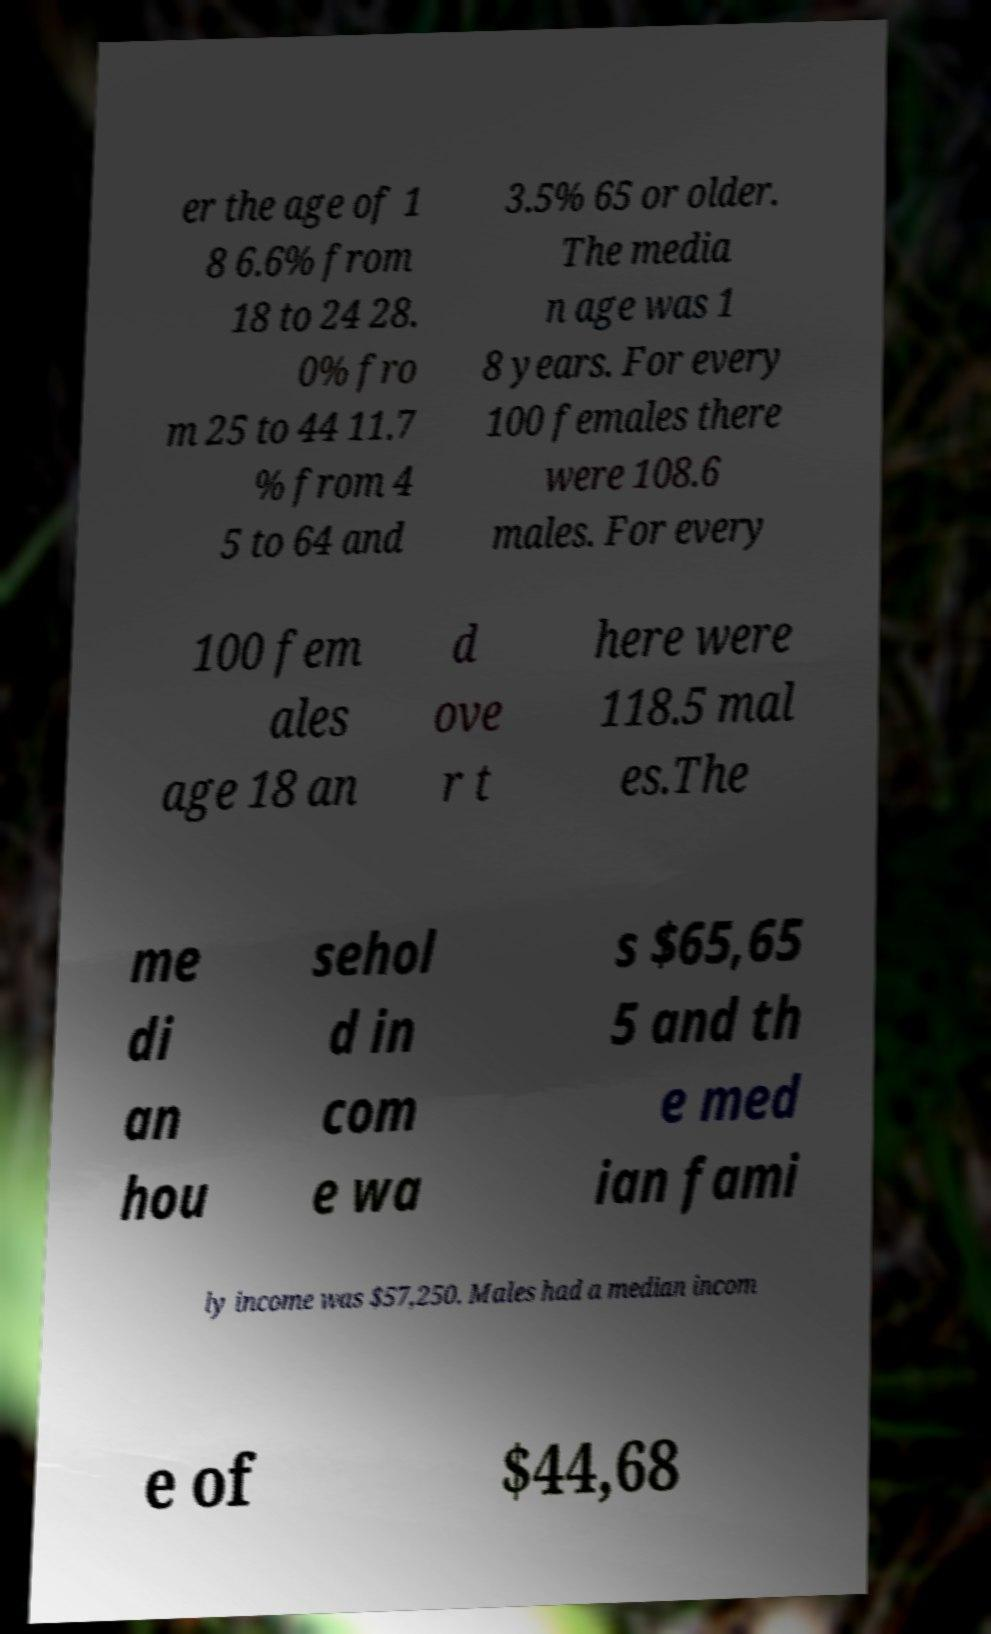There's text embedded in this image that I need extracted. Can you transcribe it verbatim? er the age of 1 8 6.6% from 18 to 24 28. 0% fro m 25 to 44 11.7 % from 4 5 to 64 and 3.5% 65 or older. The media n age was 1 8 years. For every 100 females there were 108.6 males. For every 100 fem ales age 18 an d ove r t here were 118.5 mal es.The me di an hou sehol d in com e wa s $65,65 5 and th e med ian fami ly income was $57,250. Males had a median incom e of $44,68 